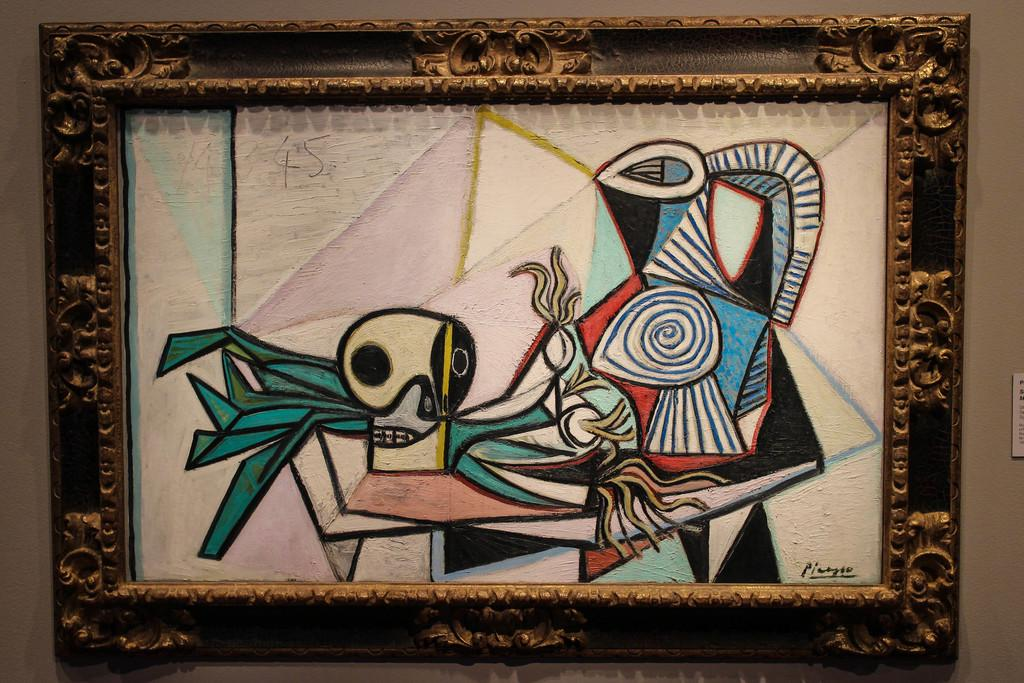What is the main subject of the image? There is a picture frame with a painting in the image. What can be seen behind the picture frame? There is a wall behind the picture frame. What else is visible in the image besides the picture frame and wall? There is an object on the right side of the image. Can you describe the fight happening between the objects in the image? There is no fight happening between objects in the image; it only features a picture frame with a painting, a wall, and an unspecified object on the right side. What type of road is visible in the image? There is no road present in the image. 